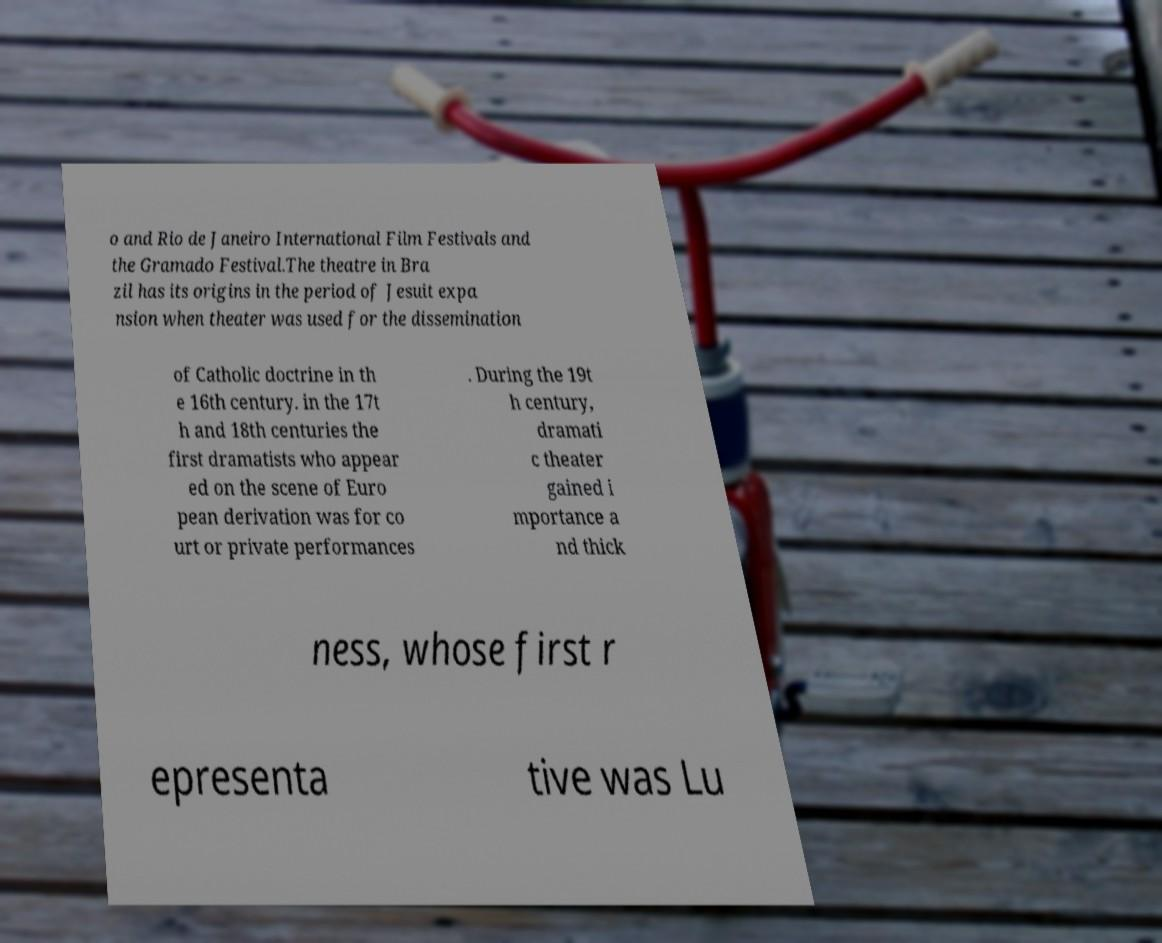For documentation purposes, I need the text within this image transcribed. Could you provide that? o and Rio de Janeiro International Film Festivals and the Gramado Festival.The theatre in Bra zil has its origins in the period of Jesuit expa nsion when theater was used for the dissemination of Catholic doctrine in th e 16th century. in the 17t h and 18th centuries the first dramatists who appear ed on the scene of Euro pean derivation was for co urt or private performances . During the 19t h century, dramati c theater gained i mportance a nd thick ness, whose first r epresenta tive was Lu 